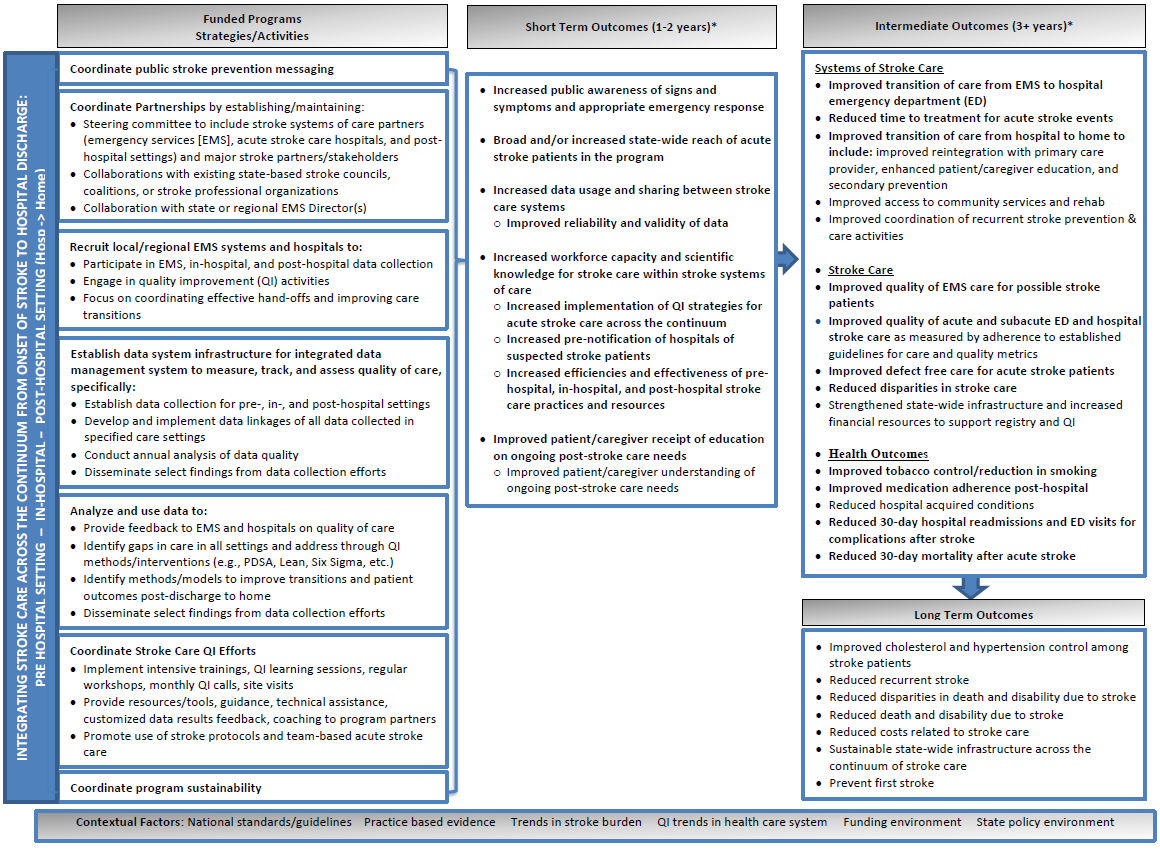Can you describe how the 'Coordinate Stroke Care QI Efforts' activity could potentially impact long-term patient outcomes as seen in the 'Long Term Outcomes' space of the image? The 'Coordinate Stroke Care QI Efforts' activity aims to enhance stroke care quality through ongoing learning, regular workshops, and customized support. These initiatives contribute to improved patient management protocols and more effective stroke treatment methodologies. As reflected in the 'Long Term Outcomes' section, such efforts could lead to better management of cholesterol and hypertension among stroke survivors, reduced recurrence of strokes, and ultimately decreased mortality rates. Implementing these quality improvement techniques contributes significantly to sustainability in stroke patient care and healthcare efficiencies over time. 